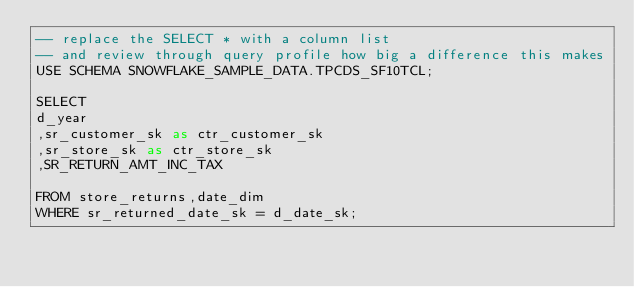Convert code to text. <code><loc_0><loc_0><loc_500><loc_500><_SQL_>-- replace the SELECT * with a column list
-- and review through query profile how big a difference this makes
USE SCHEMA SNOWFLAKE_SAMPLE_DATA.TPCDS_SF10TCL;

SELECT 
d_year
,sr_customer_sk as ctr_customer_sk
,sr_store_sk as ctr_store_sk
,SR_RETURN_AMT_INC_TAX

FROM store_returns,date_dim
WHERE sr_returned_date_sk = d_date_sk;
</code> 